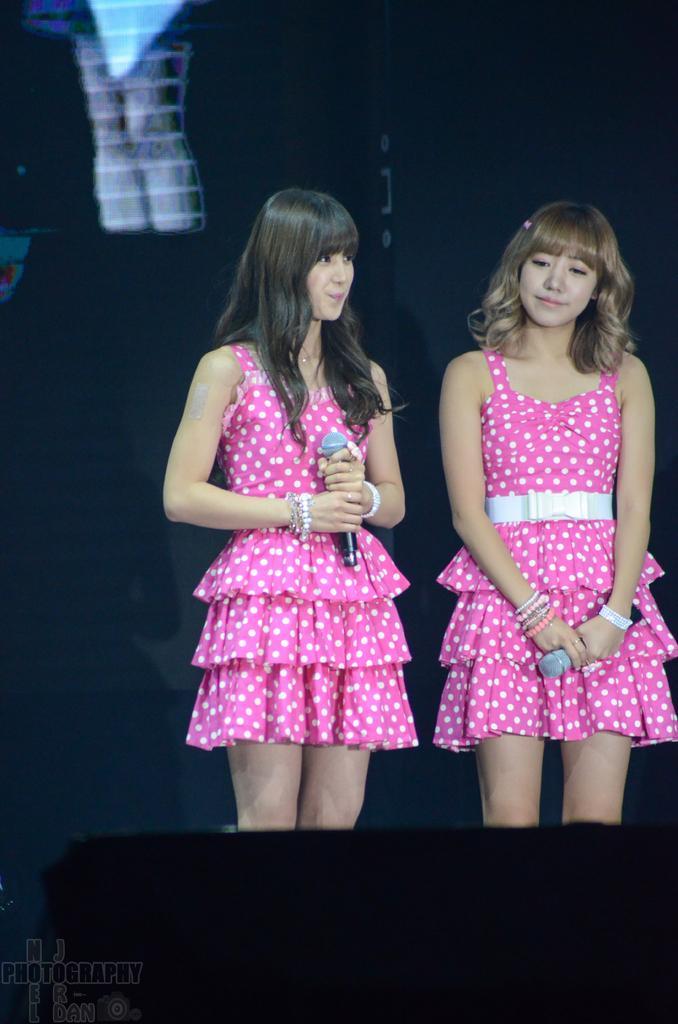How would you summarize this image in a sentence or two? In this image, there are two persons standing and wearing clothes. These two persons are holding mics with their hands. 